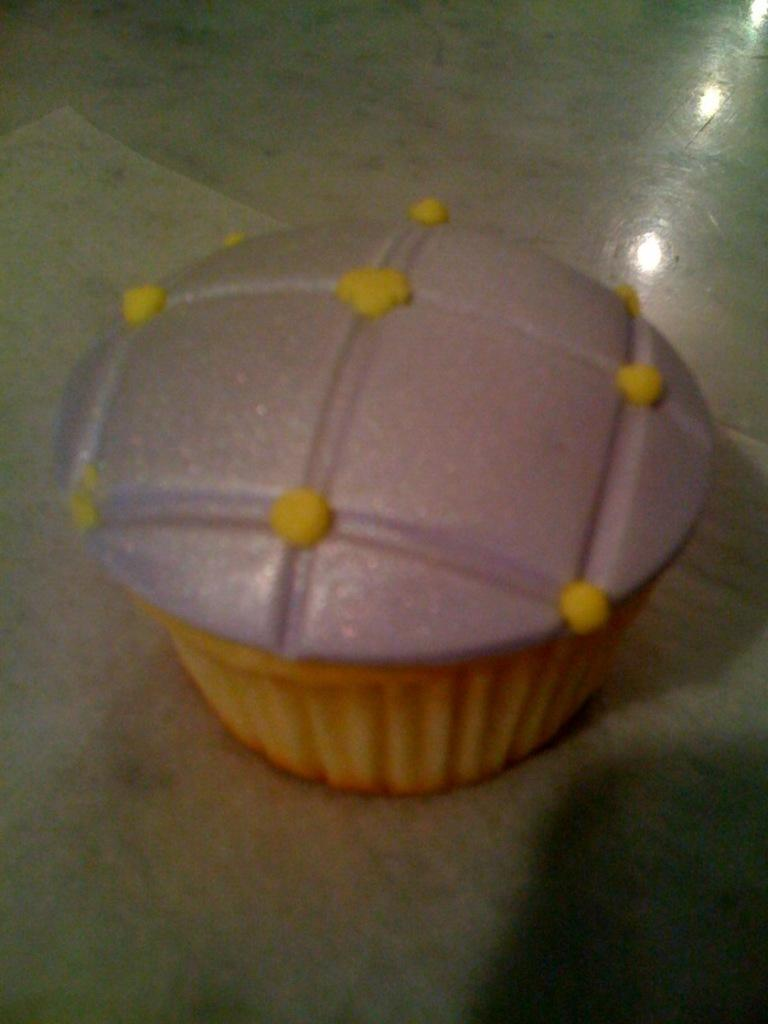What is on the floor in the image? There is a cupcake on the floor in the image. What type of silk fabric is draped over the cupcake in the image? There is no silk fabric present in the image; it only features a cupcake on the floor. 